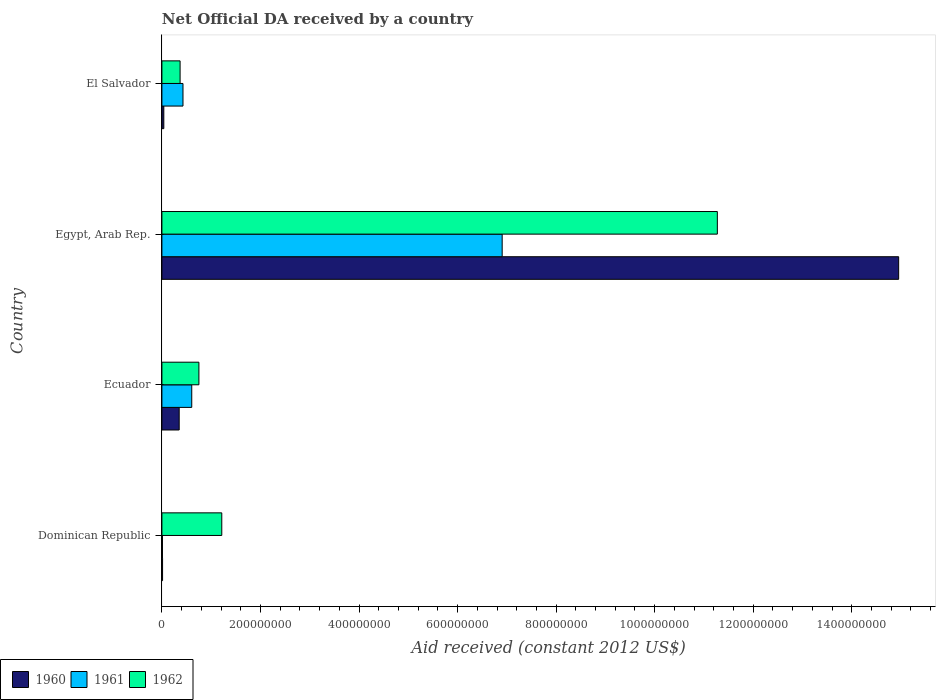What is the label of the 4th group of bars from the top?
Your answer should be very brief. Dominican Republic. What is the net official development assistance aid received in 1960 in Dominican Republic?
Your answer should be very brief. 1.34e+06. Across all countries, what is the maximum net official development assistance aid received in 1960?
Provide a short and direct response. 1.50e+09. Across all countries, what is the minimum net official development assistance aid received in 1960?
Provide a succinct answer. 1.34e+06. In which country was the net official development assistance aid received in 1962 maximum?
Provide a short and direct response. Egypt, Arab Rep. In which country was the net official development assistance aid received in 1960 minimum?
Your answer should be compact. Dominican Republic. What is the total net official development assistance aid received in 1962 in the graph?
Keep it short and to the point. 1.36e+09. What is the difference between the net official development assistance aid received in 1961 in Dominican Republic and that in Ecuador?
Provide a short and direct response. -5.94e+07. What is the difference between the net official development assistance aid received in 1961 in El Salvador and the net official development assistance aid received in 1960 in Egypt, Arab Rep.?
Ensure brevity in your answer.  -1.45e+09. What is the average net official development assistance aid received in 1961 per country?
Offer a terse response. 1.99e+08. In how many countries, is the net official development assistance aid received in 1961 greater than 520000000 US$?
Ensure brevity in your answer.  1. What is the ratio of the net official development assistance aid received in 1962 in Ecuador to that in El Salvador?
Provide a short and direct response. 2.03. Is the difference between the net official development assistance aid received in 1960 in Ecuador and Egypt, Arab Rep. greater than the difference between the net official development assistance aid received in 1961 in Ecuador and Egypt, Arab Rep.?
Your response must be concise. No. What is the difference between the highest and the second highest net official development assistance aid received in 1961?
Provide a succinct answer. 6.30e+08. What is the difference between the highest and the lowest net official development assistance aid received in 1960?
Your answer should be very brief. 1.49e+09. In how many countries, is the net official development assistance aid received in 1962 greater than the average net official development assistance aid received in 1962 taken over all countries?
Provide a short and direct response. 1. What does the 2nd bar from the top in Dominican Republic represents?
Keep it short and to the point. 1961. What does the 1st bar from the bottom in El Salvador represents?
Your response must be concise. 1960. Is it the case that in every country, the sum of the net official development assistance aid received in 1961 and net official development assistance aid received in 1962 is greater than the net official development assistance aid received in 1960?
Provide a short and direct response. Yes. Are all the bars in the graph horizontal?
Keep it short and to the point. Yes. How many countries are there in the graph?
Offer a terse response. 4. Are the values on the major ticks of X-axis written in scientific E-notation?
Ensure brevity in your answer.  No. Does the graph contain any zero values?
Your answer should be compact. No. Does the graph contain grids?
Your answer should be compact. No. Where does the legend appear in the graph?
Your answer should be very brief. Bottom left. How are the legend labels stacked?
Offer a terse response. Horizontal. What is the title of the graph?
Your answer should be compact. Net Official DA received by a country. What is the label or title of the X-axis?
Your response must be concise. Aid received (constant 2012 US$). What is the label or title of the Y-axis?
Your response must be concise. Country. What is the Aid received (constant 2012 US$) of 1960 in Dominican Republic?
Offer a terse response. 1.34e+06. What is the Aid received (constant 2012 US$) of 1961 in Dominican Republic?
Keep it short and to the point. 1.16e+06. What is the Aid received (constant 2012 US$) in 1962 in Dominican Republic?
Give a very brief answer. 1.22e+08. What is the Aid received (constant 2012 US$) in 1960 in Ecuador?
Provide a short and direct response. 3.51e+07. What is the Aid received (constant 2012 US$) of 1961 in Ecuador?
Your answer should be very brief. 6.06e+07. What is the Aid received (constant 2012 US$) of 1962 in Ecuador?
Offer a very short reply. 7.51e+07. What is the Aid received (constant 2012 US$) of 1960 in Egypt, Arab Rep.?
Provide a succinct answer. 1.50e+09. What is the Aid received (constant 2012 US$) in 1961 in Egypt, Arab Rep.?
Your response must be concise. 6.91e+08. What is the Aid received (constant 2012 US$) of 1962 in Egypt, Arab Rep.?
Your answer should be very brief. 1.13e+09. What is the Aid received (constant 2012 US$) of 1960 in El Salvador?
Keep it short and to the point. 3.89e+06. What is the Aid received (constant 2012 US$) of 1961 in El Salvador?
Provide a short and direct response. 4.28e+07. What is the Aid received (constant 2012 US$) in 1962 in El Salvador?
Your answer should be very brief. 3.69e+07. Across all countries, what is the maximum Aid received (constant 2012 US$) in 1960?
Your answer should be compact. 1.50e+09. Across all countries, what is the maximum Aid received (constant 2012 US$) of 1961?
Make the answer very short. 6.91e+08. Across all countries, what is the maximum Aid received (constant 2012 US$) in 1962?
Your answer should be compact. 1.13e+09. Across all countries, what is the minimum Aid received (constant 2012 US$) of 1960?
Offer a very short reply. 1.34e+06. Across all countries, what is the minimum Aid received (constant 2012 US$) in 1961?
Your answer should be very brief. 1.16e+06. Across all countries, what is the minimum Aid received (constant 2012 US$) of 1962?
Keep it short and to the point. 3.69e+07. What is the total Aid received (constant 2012 US$) of 1960 in the graph?
Your response must be concise. 1.54e+09. What is the total Aid received (constant 2012 US$) of 1961 in the graph?
Your answer should be compact. 7.95e+08. What is the total Aid received (constant 2012 US$) in 1962 in the graph?
Your response must be concise. 1.36e+09. What is the difference between the Aid received (constant 2012 US$) of 1960 in Dominican Republic and that in Ecuador?
Offer a terse response. -3.38e+07. What is the difference between the Aid received (constant 2012 US$) in 1961 in Dominican Republic and that in Ecuador?
Give a very brief answer. -5.94e+07. What is the difference between the Aid received (constant 2012 US$) of 1962 in Dominican Republic and that in Ecuador?
Your response must be concise. 4.64e+07. What is the difference between the Aid received (constant 2012 US$) of 1960 in Dominican Republic and that in Egypt, Arab Rep.?
Ensure brevity in your answer.  -1.49e+09. What is the difference between the Aid received (constant 2012 US$) in 1961 in Dominican Republic and that in Egypt, Arab Rep.?
Your response must be concise. -6.89e+08. What is the difference between the Aid received (constant 2012 US$) of 1962 in Dominican Republic and that in Egypt, Arab Rep.?
Provide a succinct answer. -1.01e+09. What is the difference between the Aid received (constant 2012 US$) of 1960 in Dominican Republic and that in El Salvador?
Offer a terse response. -2.55e+06. What is the difference between the Aid received (constant 2012 US$) of 1961 in Dominican Republic and that in El Salvador?
Provide a succinct answer. -4.16e+07. What is the difference between the Aid received (constant 2012 US$) of 1962 in Dominican Republic and that in El Salvador?
Your answer should be very brief. 8.46e+07. What is the difference between the Aid received (constant 2012 US$) of 1960 in Ecuador and that in Egypt, Arab Rep.?
Ensure brevity in your answer.  -1.46e+09. What is the difference between the Aid received (constant 2012 US$) in 1961 in Ecuador and that in Egypt, Arab Rep.?
Provide a succinct answer. -6.30e+08. What is the difference between the Aid received (constant 2012 US$) in 1962 in Ecuador and that in Egypt, Arab Rep.?
Provide a short and direct response. -1.05e+09. What is the difference between the Aid received (constant 2012 US$) in 1960 in Ecuador and that in El Salvador?
Provide a short and direct response. 3.12e+07. What is the difference between the Aid received (constant 2012 US$) in 1961 in Ecuador and that in El Salvador?
Provide a short and direct response. 1.78e+07. What is the difference between the Aid received (constant 2012 US$) of 1962 in Ecuador and that in El Salvador?
Offer a very short reply. 3.82e+07. What is the difference between the Aid received (constant 2012 US$) in 1960 in Egypt, Arab Rep. and that in El Salvador?
Offer a terse response. 1.49e+09. What is the difference between the Aid received (constant 2012 US$) in 1961 in Egypt, Arab Rep. and that in El Salvador?
Offer a very short reply. 6.48e+08. What is the difference between the Aid received (constant 2012 US$) of 1962 in Egypt, Arab Rep. and that in El Salvador?
Offer a terse response. 1.09e+09. What is the difference between the Aid received (constant 2012 US$) of 1960 in Dominican Republic and the Aid received (constant 2012 US$) of 1961 in Ecuador?
Provide a short and direct response. -5.92e+07. What is the difference between the Aid received (constant 2012 US$) in 1960 in Dominican Republic and the Aid received (constant 2012 US$) in 1962 in Ecuador?
Ensure brevity in your answer.  -7.38e+07. What is the difference between the Aid received (constant 2012 US$) of 1961 in Dominican Republic and the Aid received (constant 2012 US$) of 1962 in Ecuador?
Your answer should be compact. -7.39e+07. What is the difference between the Aid received (constant 2012 US$) in 1960 in Dominican Republic and the Aid received (constant 2012 US$) in 1961 in Egypt, Arab Rep.?
Offer a terse response. -6.89e+08. What is the difference between the Aid received (constant 2012 US$) in 1960 in Dominican Republic and the Aid received (constant 2012 US$) in 1962 in Egypt, Arab Rep.?
Provide a short and direct response. -1.13e+09. What is the difference between the Aid received (constant 2012 US$) in 1961 in Dominican Republic and the Aid received (constant 2012 US$) in 1962 in Egypt, Arab Rep.?
Ensure brevity in your answer.  -1.13e+09. What is the difference between the Aid received (constant 2012 US$) of 1960 in Dominican Republic and the Aid received (constant 2012 US$) of 1961 in El Salvador?
Offer a terse response. -4.14e+07. What is the difference between the Aid received (constant 2012 US$) of 1960 in Dominican Republic and the Aid received (constant 2012 US$) of 1962 in El Salvador?
Your answer should be compact. -3.56e+07. What is the difference between the Aid received (constant 2012 US$) in 1961 in Dominican Republic and the Aid received (constant 2012 US$) in 1962 in El Salvador?
Give a very brief answer. -3.58e+07. What is the difference between the Aid received (constant 2012 US$) of 1960 in Ecuador and the Aid received (constant 2012 US$) of 1961 in Egypt, Arab Rep.?
Your answer should be very brief. -6.55e+08. What is the difference between the Aid received (constant 2012 US$) of 1960 in Ecuador and the Aid received (constant 2012 US$) of 1962 in Egypt, Arab Rep.?
Provide a short and direct response. -1.09e+09. What is the difference between the Aid received (constant 2012 US$) of 1961 in Ecuador and the Aid received (constant 2012 US$) of 1962 in Egypt, Arab Rep.?
Provide a short and direct response. -1.07e+09. What is the difference between the Aid received (constant 2012 US$) of 1960 in Ecuador and the Aid received (constant 2012 US$) of 1961 in El Salvador?
Your response must be concise. -7.69e+06. What is the difference between the Aid received (constant 2012 US$) in 1960 in Ecuador and the Aid received (constant 2012 US$) in 1962 in El Salvador?
Give a very brief answer. -1.83e+06. What is the difference between the Aid received (constant 2012 US$) in 1961 in Ecuador and the Aid received (constant 2012 US$) in 1962 in El Salvador?
Provide a succinct answer. 2.37e+07. What is the difference between the Aid received (constant 2012 US$) of 1960 in Egypt, Arab Rep. and the Aid received (constant 2012 US$) of 1961 in El Salvador?
Provide a succinct answer. 1.45e+09. What is the difference between the Aid received (constant 2012 US$) in 1960 in Egypt, Arab Rep. and the Aid received (constant 2012 US$) in 1962 in El Salvador?
Give a very brief answer. 1.46e+09. What is the difference between the Aid received (constant 2012 US$) in 1961 in Egypt, Arab Rep. and the Aid received (constant 2012 US$) in 1962 in El Salvador?
Make the answer very short. 6.54e+08. What is the average Aid received (constant 2012 US$) of 1960 per country?
Offer a terse response. 3.84e+08. What is the average Aid received (constant 2012 US$) in 1961 per country?
Give a very brief answer. 1.99e+08. What is the average Aid received (constant 2012 US$) in 1962 per country?
Your answer should be very brief. 3.40e+08. What is the difference between the Aid received (constant 2012 US$) in 1960 and Aid received (constant 2012 US$) in 1961 in Dominican Republic?
Keep it short and to the point. 1.80e+05. What is the difference between the Aid received (constant 2012 US$) in 1960 and Aid received (constant 2012 US$) in 1962 in Dominican Republic?
Offer a very short reply. -1.20e+08. What is the difference between the Aid received (constant 2012 US$) of 1961 and Aid received (constant 2012 US$) of 1962 in Dominican Republic?
Provide a short and direct response. -1.20e+08. What is the difference between the Aid received (constant 2012 US$) of 1960 and Aid received (constant 2012 US$) of 1961 in Ecuador?
Give a very brief answer. -2.55e+07. What is the difference between the Aid received (constant 2012 US$) of 1960 and Aid received (constant 2012 US$) of 1962 in Ecuador?
Your answer should be compact. -4.00e+07. What is the difference between the Aid received (constant 2012 US$) of 1961 and Aid received (constant 2012 US$) of 1962 in Ecuador?
Your answer should be compact. -1.45e+07. What is the difference between the Aid received (constant 2012 US$) of 1960 and Aid received (constant 2012 US$) of 1961 in Egypt, Arab Rep.?
Make the answer very short. 8.05e+08. What is the difference between the Aid received (constant 2012 US$) of 1960 and Aid received (constant 2012 US$) of 1962 in Egypt, Arab Rep.?
Your answer should be compact. 3.68e+08. What is the difference between the Aid received (constant 2012 US$) of 1961 and Aid received (constant 2012 US$) of 1962 in Egypt, Arab Rep.?
Offer a terse response. -4.37e+08. What is the difference between the Aid received (constant 2012 US$) in 1960 and Aid received (constant 2012 US$) in 1961 in El Salvador?
Offer a very short reply. -3.89e+07. What is the difference between the Aid received (constant 2012 US$) in 1960 and Aid received (constant 2012 US$) in 1962 in El Salvador?
Your response must be concise. -3.30e+07. What is the difference between the Aid received (constant 2012 US$) of 1961 and Aid received (constant 2012 US$) of 1962 in El Salvador?
Your answer should be compact. 5.86e+06. What is the ratio of the Aid received (constant 2012 US$) of 1960 in Dominican Republic to that in Ecuador?
Your answer should be compact. 0.04. What is the ratio of the Aid received (constant 2012 US$) of 1961 in Dominican Republic to that in Ecuador?
Your answer should be compact. 0.02. What is the ratio of the Aid received (constant 2012 US$) in 1962 in Dominican Republic to that in Ecuador?
Offer a terse response. 1.62. What is the ratio of the Aid received (constant 2012 US$) in 1960 in Dominican Republic to that in Egypt, Arab Rep.?
Make the answer very short. 0. What is the ratio of the Aid received (constant 2012 US$) in 1961 in Dominican Republic to that in Egypt, Arab Rep.?
Make the answer very short. 0. What is the ratio of the Aid received (constant 2012 US$) of 1962 in Dominican Republic to that in Egypt, Arab Rep.?
Give a very brief answer. 0.11. What is the ratio of the Aid received (constant 2012 US$) in 1960 in Dominican Republic to that in El Salvador?
Provide a short and direct response. 0.34. What is the ratio of the Aid received (constant 2012 US$) of 1961 in Dominican Republic to that in El Salvador?
Give a very brief answer. 0.03. What is the ratio of the Aid received (constant 2012 US$) in 1962 in Dominican Republic to that in El Salvador?
Offer a terse response. 3.29. What is the ratio of the Aid received (constant 2012 US$) of 1960 in Ecuador to that in Egypt, Arab Rep.?
Keep it short and to the point. 0.02. What is the ratio of the Aid received (constant 2012 US$) of 1961 in Ecuador to that in Egypt, Arab Rep.?
Ensure brevity in your answer.  0.09. What is the ratio of the Aid received (constant 2012 US$) in 1962 in Ecuador to that in Egypt, Arab Rep.?
Give a very brief answer. 0.07. What is the ratio of the Aid received (constant 2012 US$) of 1960 in Ecuador to that in El Salvador?
Make the answer very short. 9.02. What is the ratio of the Aid received (constant 2012 US$) in 1961 in Ecuador to that in El Salvador?
Give a very brief answer. 1.42. What is the ratio of the Aid received (constant 2012 US$) of 1962 in Ecuador to that in El Salvador?
Provide a succinct answer. 2.03. What is the ratio of the Aid received (constant 2012 US$) of 1960 in Egypt, Arab Rep. to that in El Salvador?
Your response must be concise. 384.33. What is the ratio of the Aid received (constant 2012 US$) of 1961 in Egypt, Arab Rep. to that in El Salvador?
Give a very brief answer. 16.14. What is the ratio of the Aid received (constant 2012 US$) of 1962 in Egypt, Arab Rep. to that in El Salvador?
Your response must be concise. 30.53. What is the difference between the highest and the second highest Aid received (constant 2012 US$) of 1960?
Your answer should be very brief. 1.46e+09. What is the difference between the highest and the second highest Aid received (constant 2012 US$) in 1961?
Ensure brevity in your answer.  6.30e+08. What is the difference between the highest and the second highest Aid received (constant 2012 US$) of 1962?
Your answer should be very brief. 1.01e+09. What is the difference between the highest and the lowest Aid received (constant 2012 US$) in 1960?
Provide a succinct answer. 1.49e+09. What is the difference between the highest and the lowest Aid received (constant 2012 US$) in 1961?
Ensure brevity in your answer.  6.89e+08. What is the difference between the highest and the lowest Aid received (constant 2012 US$) in 1962?
Provide a succinct answer. 1.09e+09. 